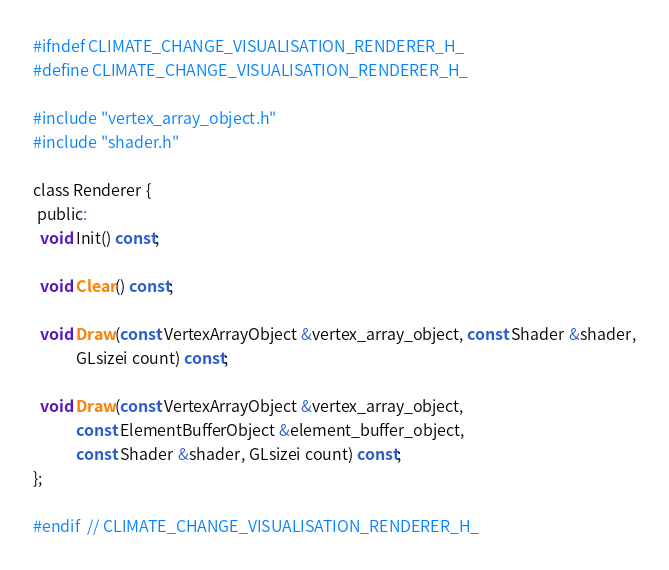<code> <loc_0><loc_0><loc_500><loc_500><_C_>#ifndef CLIMATE_CHANGE_VISUALISATION_RENDERER_H_
#define CLIMATE_CHANGE_VISUALISATION_RENDERER_H_

#include "vertex_array_object.h"
#include "shader.h"

class Renderer {
 public:
  void Init() const;

  void Clear() const;

  void Draw(const VertexArrayObject &vertex_array_object, const Shader &shader,
            GLsizei count) const;

  void Draw(const VertexArrayObject &vertex_array_object,
            const ElementBufferObject &element_buffer_object,
            const Shader &shader, GLsizei count) const;
};

#endif  // CLIMATE_CHANGE_VISUALISATION_RENDERER_H_
</code> 